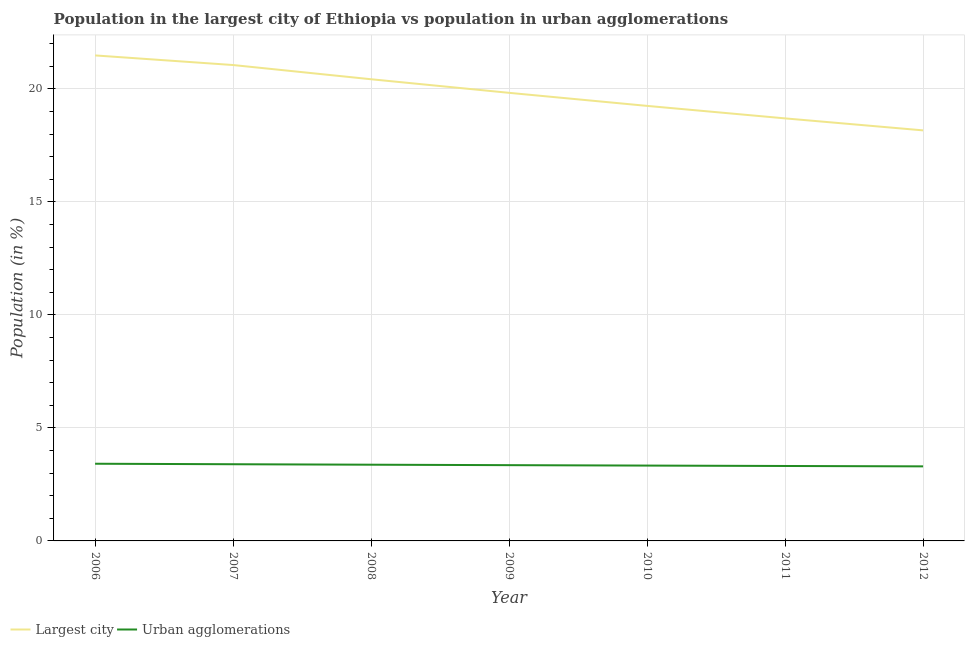Does the line corresponding to population in the largest city intersect with the line corresponding to population in urban agglomerations?
Your response must be concise. No. What is the population in urban agglomerations in 2008?
Give a very brief answer. 3.37. Across all years, what is the maximum population in urban agglomerations?
Your response must be concise. 3.42. Across all years, what is the minimum population in urban agglomerations?
Provide a succinct answer. 3.3. In which year was the population in the largest city minimum?
Keep it short and to the point. 2012. What is the total population in the largest city in the graph?
Provide a short and direct response. 138.89. What is the difference between the population in the largest city in 2010 and that in 2011?
Provide a succinct answer. 0.55. What is the difference between the population in urban agglomerations in 2006 and the population in the largest city in 2008?
Ensure brevity in your answer.  -17.01. What is the average population in urban agglomerations per year?
Make the answer very short. 3.35. In the year 2006, what is the difference between the population in the largest city and population in urban agglomerations?
Give a very brief answer. 18.06. In how many years, is the population in urban agglomerations greater than 10 %?
Make the answer very short. 0. What is the ratio of the population in the largest city in 2009 to that in 2010?
Provide a succinct answer. 1.03. What is the difference between the highest and the second highest population in the largest city?
Provide a succinct answer. 0.43. What is the difference between the highest and the lowest population in the largest city?
Your answer should be very brief. 3.32. Does the population in the largest city monotonically increase over the years?
Keep it short and to the point. No. Is the population in urban agglomerations strictly greater than the population in the largest city over the years?
Make the answer very short. No. Is the population in the largest city strictly less than the population in urban agglomerations over the years?
Your answer should be compact. No. How many lines are there?
Provide a succinct answer. 2. How many years are there in the graph?
Give a very brief answer. 7. What is the difference between two consecutive major ticks on the Y-axis?
Provide a succinct answer. 5. Does the graph contain grids?
Your response must be concise. Yes. How are the legend labels stacked?
Make the answer very short. Horizontal. What is the title of the graph?
Ensure brevity in your answer.  Population in the largest city of Ethiopia vs population in urban agglomerations. What is the label or title of the Y-axis?
Offer a terse response. Population (in %). What is the Population (in %) of Largest city in 2006?
Keep it short and to the point. 21.48. What is the Population (in %) of Urban agglomerations in 2006?
Provide a succinct answer. 3.42. What is the Population (in %) of Largest city in 2007?
Provide a short and direct response. 21.05. What is the Population (in %) in Urban agglomerations in 2007?
Provide a succinct answer. 3.39. What is the Population (in %) of Largest city in 2008?
Offer a very short reply. 20.43. What is the Population (in %) of Urban agglomerations in 2008?
Your answer should be compact. 3.37. What is the Population (in %) of Largest city in 2009?
Provide a succinct answer. 19.82. What is the Population (in %) of Urban agglomerations in 2009?
Keep it short and to the point. 3.35. What is the Population (in %) of Largest city in 2010?
Keep it short and to the point. 19.25. What is the Population (in %) of Urban agglomerations in 2010?
Provide a short and direct response. 3.33. What is the Population (in %) in Largest city in 2011?
Provide a short and direct response. 18.69. What is the Population (in %) of Urban agglomerations in 2011?
Offer a terse response. 3.32. What is the Population (in %) of Largest city in 2012?
Your response must be concise. 18.16. What is the Population (in %) in Urban agglomerations in 2012?
Offer a terse response. 3.3. Across all years, what is the maximum Population (in %) in Largest city?
Your response must be concise. 21.48. Across all years, what is the maximum Population (in %) of Urban agglomerations?
Keep it short and to the point. 3.42. Across all years, what is the minimum Population (in %) in Largest city?
Offer a terse response. 18.16. Across all years, what is the minimum Population (in %) of Urban agglomerations?
Offer a terse response. 3.3. What is the total Population (in %) of Largest city in the graph?
Give a very brief answer. 138.89. What is the total Population (in %) in Urban agglomerations in the graph?
Offer a very short reply. 23.48. What is the difference between the Population (in %) of Largest city in 2006 and that in 2007?
Make the answer very short. 0.43. What is the difference between the Population (in %) of Urban agglomerations in 2006 and that in 2007?
Provide a short and direct response. 0.02. What is the difference between the Population (in %) in Largest city in 2006 and that in 2008?
Your answer should be very brief. 1.05. What is the difference between the Population (in %) in Urban agglomerations in 2006 and that in 2008?
Give a very brief answer. 0.04. What is the difference between the Population (in %) in Largest city in 2006 and that in 2009?
Offer a terse response. 1.66. What is the difference between the Population (in %) in Urban agglomerations in 2006 and that in 2009?
Your answer should be very brief. 0.06. What is the difference between the Population (in %) in Largest city in 2006 and that in 2010?
Provide a succinct answer. 2.23. What is the difference between the Population (in %) of Urban agglomerations in 2006 and that in 2010?
Your response must be concise. 0.08. What is the difference between the Population (in %) in Largest city in 2006 and that in 2011?
Your answer should be compact. 2.79. What is the difference between the Population (in %) of Urban agglomerations in 2006 and that in 2011?
Offer a very short reply. 0.1. What is the difference between the Population (in %) of Largest city in 2006 and that in 2012?
Your response must be concise. 3.32. What is the difference between the Population (in %) in Urban agglomerations in 2006 and that in 2012?
Provide a short and direct response. 0.12. What is the difference between the Population (in %) of Largest city in 2007 and that in 2008?
Offer a very short reply. 0.63. What is the difference between the Population (in %) of Urban agglomerations in 2007 and that in 2008?
Offer a very short reply. 0.02. What is the difference between the Population (in %) of Largest city in 2007 and that in 2009?
Keep it short and to the point. 1.23. What is the difference between the Population (in %) in Urban agglomerations in 2007 and that in 2009?
Provide a succinct answer. 0.04. What is the difference between the Population (in %) of Largest city in 2007 and that in 2010?
Offer a terse response. 1.81. What is the difference between the Population (in %) in Urban agglomerations in 2007 and that in 2010?
Offer a terse response. 0.06. What is the difference between the Population (in %) of Largest city in 2007 and that in 2011?
Your answer should be very brief. 2.36. What is the difference between the Population (in %) of Urban agglomerations in 2007 and that in 2011?
Offer a very short reply. 0.08. What is the difference between the Population (in %) in Largest city in 2007 and that in 2012?
Provide a succinct answer. 2.89. What is the difference between the Population (in %) of Urban agglomerations in 2007 and that in 2012?
Provide a succinct answer. 0.09. What is the difference between the Population (in %) in Largest city in 2008 and that in 2009?
Keep it short and to the point. 0.6. What is the difference between the Population (in %) in Largest city in 2008 and that in 2010?
Provide a short and direct response. 1.18. What is the difference between the Population (in %) in Urban agglomerations in 2008 and that in 2010?
Provide a succinct answer. 0.04. What is the difference between the Population (in %) in Largest city in 2008 and that in 2011?
Offer a terse response. 1.73. What is the difference between the Population (in %) in Urban agglomerations in 2008 and that in 2011?
Your response must be concise. 0.06. What is the difference between the Population (in %) of Largest city in 2008 and that in 2012?
Make the answer very short. 2.26. What is the difference between the Population (in %) of Urban agglomerations in 2008 and that in 2012?
Provide a succinct answer. 0.07. What is the difference between the Population (in %) of Largest city in 2009 and that in 2010?
Make the answer very short. 0.58. What is the difference between the Population (in %) of Urban agglomerations in 2009 and that in 2010?
Give a very brief answer. 0.02. What is the difference between the Population (in %) in Largest city in 2009 and that in 2011?
Provide a short and direct response. 1.13. What is the difference between the Population (in %) in Urban agglomerations in 2009 and that in 2011?
Your answer should be compact. 0.04. What is the difference between the Population (in %) in Largest city in 2009 and that in 2012?
Provide a succinct answer. 1.66. What is the difference between the Population (in %) of Urban agglomerations in 2009 and that in 2012?
Offer a terse response. 0.05. What is the difference between the Population (in %) in Largest city in 2010 and that in 2011?
Your response must be concise. 0.55. What is the difference between the Population (in %) in Urban agglomerations in 2010 and that in 2011?
Offer a very short reply. 0.02. What is the difference between the Population (in %) in Largest city in 2010 and that in 2012?
Your answer should be compact. 1.08. What is the difference between the Population (in %) in Urban agglomerations in 2010 and that in 2012?
Give a very brief answer. 0.03. What is the difference between the Population (in %) of Largest city in 2011 and that in 2012?
Your answer should be very brief. 0.53. What is the difference between the Population (in %) in Urban agglomerations in 2011 and that in 2012?
Your answer should be very brief. 0.02. What is the difference between the Population (in %) of Largest city in 2006 and the Population (in %) of Urban agglomerations in 2007?
Make the answer very short. 18.09. What is the difference between the Population (in %) of Largest city in 2006 and the Population (in %) of Urban agglomerations in 2008?
Offer a very short reply. 18.11. What is the difference between the Population (in %) of Largest city in 2006 and the Population (in %) of Urban agglomerations in 2009?
Your answer should be very brief. 18.13. What is the difference between the Population (in %) of Largest city in 2006 and the Population (in %) of Urban agglomerations in 2010?
Make the answer very short. 18.15. What is the difference between the Population (in %) of Largest city in 2006 and the Population (in %) of Urban agglomerations in 2011?
Give a very brief answer. 18.16. What is the difference between the Population (in %) in Largest city in 2006 and the Population (in %) in Urban agglomerations in 2012?
Offer a very short reply. 18.18. What is the difference between the Population (in %) of Largest city in 2007 and the Population (in %) of Urban agglomerations in 2008?
Your answer should be compact. 17.68. What is the difference between the Population (in %) in Largest city in 2007 and the Population (in %) in Urban agglomerations in 2009?
Your answer should be compact. 17.7. What is the difference between the Population (in %) of Largest city in 2007 and the Population (in %) of Urban agglomerations in 2010?
Provide a short and direct response. 17.72. What is the difference between the Population (in %) in Largest city in 2007 and the Population (in %) in Urban agglomerations in 2011?
Your response must be concise. 17.74. What is the difference between the Population (in %) in Largest city in 2007 and the Population (in %) in Urban agglomerations in 2012?
Make the answer very short. 17.76. What is the difference between the Population (in %) of Largest city in 2008 and the Population (in %) of Urban agglomerations in 2009?
Make the answer very short. 17.07. What is the difference between the Population (in %) in Largest city in 2008 and the Population (in %) in Urban agglomerations in 2010?
Offer a very short reply. 17.09. What is the difference between the Population (in %) in Largest city in 2008 and the Population (in %) in Urban agglomerations in 2011?
Offer a terse response. 17.11. What is the difference between the Population (in %) in Largest city in 2008 and the Population (in %) in Urban agglomerations in 2012?
Your answer should be very brief. 17.13. What is the difference between the Population (in %) in Largest city in 2009 and the Population (in %) in Urban agglomerations in 2010?
Your answer should be very brief. 16.49. What is the difference between the Population (in %) of Largest city in 2009 and the Population (in %) of Urban agglomerations in 2011?
Your response must be concise. 16.51. What is the difference between the Population (in %) in Largest city in 2009 and the Population (in %) in Urban agglomerations in 2012?
Your answer should be compact. 16.53. What is the difference between the Population (in %) of Largest city in 2010 and the Population (in %) of Urban agglomerations in 2011?
Ensure brevity in your answer.  15.93. What is the difference between the Population (in %) of Largest city in 2010 and the Population (in %) of Urban agglomerations in 2012?
Provide a short and direct response. 15.95. What is the difference between the Population (in %) in Largest city in 2011 and the Population (in %) in Urban agglomerations in 2012?
Offer a terse response. 15.4. What is the average Population (in %) in Largest city per year?
Provide a succinct answer. 19.84. What is the average Population (in %) in Urban agglomerations per year?
Keep it short and to the point. 3.35. In the year 2006, what is the difference between the Population (in %) in Largest city and Population (in %) in Urban agglomerations?
Your response must be concise. 18.06. In the year 2007, what is the difference between the Population (in %) of Largest city and Population (in %) of Urban agglomerations?
Provide a short and direct response. 17.66. In the year 2008, what is the difference between the Population (in %) in Largest city and Population (in %) in Urban agglomerations?
Offer a very short reply. 17.05. In the year 2009, what is the difference between the Population (in %) of Largest city and Population (in %) of Urban agglomerations?
Provide a succinct answer. 16.47. In the year 2010, what is the difference between the Population (in %) of Largest city and Population (in %) of Urban agglomerations?
Your answer should be compact. 15.91. In the year 2011, what is the difference between the Population (in %) in Largest city and Population (in %) in Urban agglomerations?
Give a very brief answer. 15.38. In the year 2012, what is the difference between the Population (in %) of Largest city and Population (in %) of Urban agglomerations?
Provide a short and direct response. 14.87. What is the ratio of the Population (in %) of Largest city in 2006 to that in 2007?
Your answer should be very brief. 1.02. What is the ratio of the Population (in %) in Largest city in 2006 to that in 2008?
Give a very brief answer. 1.05. What is the ratio of the Population (in %) of Urban agglomerations in 2006 to that in 2008?
Your answer should be very brief. 1.01. What is the ratio of the Population (in %) of Largest city in 2006 to that in 2009?
Make the answer very short. 1.08. What is the ratio of the Population (in %) of Urban agglomerations in 2006 to that in 2009?
Your answer should be very brief. 1.02. What is the ratio of the Population (in %) of Largest city in 2006 to that in 2010?
Your answer should be very brief. 1.12. What is the ratio of the Population (in %) of Urban agglomerations in 2006 to that in 2010?
Your answer should be very brief. 1.02. What is the ratio of the Population (in %) of Largest city in 2006 to that in 2011?
Give a very brief answer. 1.15. What is the ratio of the Population (in %) in Urban agglomerations in 2006 to that in 2011?
Give a very brief answer. 1.03. What is the ratio of the Population (in %) in Largest city in 2006 to that in 2012?
Keep it short and to the point. 1.18. What is the ratio of the Population (in %) of Urban agglomerations in 2006 to that in 2012?
Keep it short and to the point. 1.04. What is the ratio of the Population (in %) in Largest city in 2007 to that in 2008?
Your response must be concise. 1.03. What is the ratio of the Population (in %) of Urban agglomerations in 2007 to that in 2008?
Your answer should be compact. 1.01. What is the ratio of the Population (in %) in Largest city in 2007 to that in 2009?
Provide a succinct answer. 1.06. What is the ratio of the Population (in %) in Urban agglomerations in 2007 to that in 2009?
Provide a succinct answer. 1.01. What is the ratio of the Population (in %) of Largest city in 2007 to that in 2010?
Provide a short and direct response. 1.09. What is the ratio of the Population (in %) in Urban agglomerations in 2007 to that in 2010?
Provide a short and direct response. 1.02. What is the ratio of the Population (in %) of Largest city in 2007 to that in 2011?
Your answer should be very brief. 1.13. What is the ratio of the Population (in %) in Urban agglomerations in 2007 to that in 2011?
Your answer should be very brief. 1.02. What is the ratio of the Population (in %) in Largest city in 2007 to that in 2012?
Your answer should be very brief. 1.16. What is the ratio of the Population (in %) of Urban agglomerations in 2007 to that in 2012?
Offer a very short reply. 1.03. What is the ratio of the Population (in %) of Largest city in 2008 to that in 2009?
Offer a very short reply. 1.03. What is the ratio of the Population (in %) of Urban agglomerations in 2008 to that in 2009?
Your response must be concise. 1.01. What is the ratio of the Population (in %) in Largest city in 2008 to that in 2010?
Ensure brevity in your answer.  1.06. What is the ratio of the Population (in %) in Urban agglomerations in 2008 to that in 2010?
Ensure brevity in your answer.  1.01. What is the ratio of the Population (in %) in Largest city in 2008 to that in 2011?
Make the answer very short. 1.09. What is the ratio of the Population (in %) of Urban agglomerations in 2008 to that in 2011?
Give a very brief answer. 1.02. What is the ratio of the Population (in %) of Largest city in 2008 to that in 2012?
Provide a short and direct response. 1.12. What is the ratio of the Population (in %) in Urban agglomerations in 2008 to that in 2012?
Give a very brief answer. 1.02. What is the ratio of the Population (in %) in Largest city in 2009 to that in 2010?
Offer a terse response. 1.03. What is the ratio of the Population (in %) of Largest city in 2009 to that in 2011?
Offer a very short reply. 1.06. What is the ratio of the Population (in %) of Urban agglomerations in 2009 to that in 2011?
Your answer should be very brief. 1.01. What is the ratio of the Population (in %) of Largest city in 2009 to that in 2012?
Ensure brevity in your answer.  1.09. What is the ratio of the Population (in %) of Urban agglomerations in 2009 to that in 2012?
Keep it short and to the point. 1.02. What is the ratio of the Population (in %) of Largest city in 2010 to that in 2011?
Make the answer very short. 1.03. What is the ratio of the Population (in %) in Urban agglomerations in 2010 to that in 2011?
Offer a terse response. 1.01. What is the ratio of the Population (in %) in Largest city in 2010 to that in 2012?
Ensure brevity in your answer.  1.06. What is the ratio of the Population (in %) of Urban agglomerations in 2010 to that in 2012?
Ensure brevity in your answer.  1.01. What is the ratio of the Population (in %) of Largest city in 2011 to that in 2012?
Your answer should be compact. 1.03. What is the ratio of the Population (in %) of Urban agglomerations in 2011 to that in 2012?
Keep it short and to the point. 1.01. What is the difference between the highest and the second highest Population (in %) of Largest city?
Your answer should be very brief. 0.43. What is the difference between the highest and the second highest Population (in %) of Urban agglomerations?
Offer a terse response. 0.02. What is the difference between the highest and the lowest Population (in %) of Largest city?
Provide a succinct answer. 3.32. What is the difference between the highest and the lowest Population (in %) of Urban agglomerations?
Offer a terse response. 0.12. 